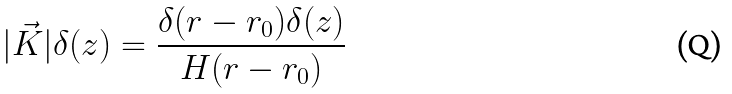Convert formula to latex. <formula><loc_0><loc_0><loc_500><loc_500>| \vec { K } | { \delta } ( z ) = \frac { { \delta } ( r - r _ { 0 } ) { \delta } ( z ) } { H ( r - r _ { 0 } ) }</formula> 